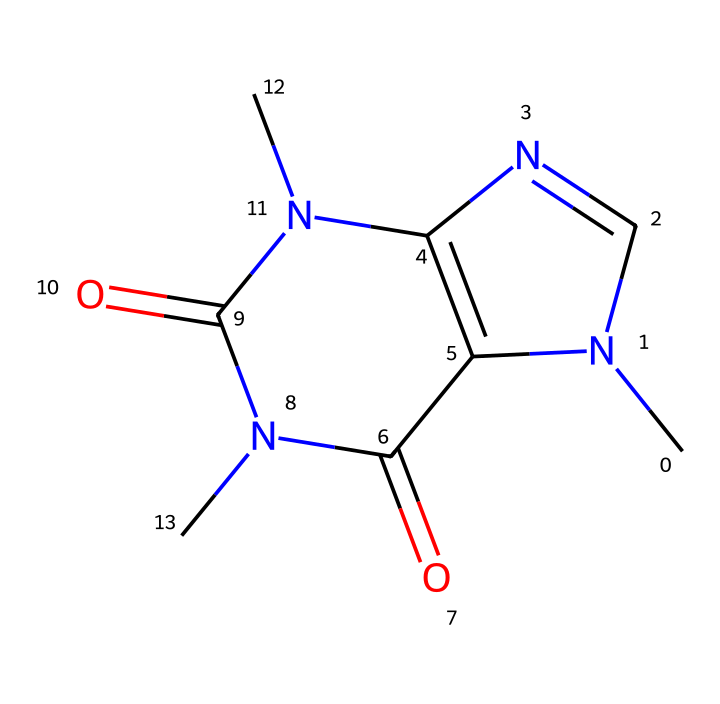What is the molecular formula of caffeine? By analyzing the SMILES representation, we can count the atoms: there are 8 carbon (C), 10 hydrogen (H), 4 nitrogen (N), and 2 oxygen (O) atoms present, leading to the formula C8H10N4O2.
Answer: C8H10N4O2 How many nitrogen atoms are in caffeine? From the SMILES representation, we can identify that there are 4 nitrogen atoms, as denoted by the presence of the letter 'N' in the structure.
Answer: 4 What type of chemical structure does caffeine have? Caffeine has a fused bicyclic structure, which can be identified by analyzing the connections and the arrangement of rings in the SMILES representation.
Answer: bicyclic Does caffeine contain any double bonds? Upon examining the structure, we notice that there are carbon-nitrogen double bonds indicated in the representation, confirming the presence of double bonds in caffeine.
Answer: yes What are the main functional groups present in caffeine? By analyzing the SMILES, we can identify that caffeine contains amine (due to nitrogen atoms) and carbonyl groups (indicated by the =O structure), which are key to its functionality.
Answer: amine, carbonyl Why is caffeine considered a stimulant? The structure of caffeine, specifically its nitrogenous base, allows it to block adenosine receptors in the brain, which enhances alertness and reduces fatigue, characteristic of stimulants.
Answer: blocks adenosine receptors How does the number of carbon atoms in caffeine compare to typical bases? Caffeine contains 8 carbon atoms, which is moderate compared to other common bases; typically, bases might range from simple structures with fewer than 5 carbon atoms to more complex ones.
Answer: moderate 